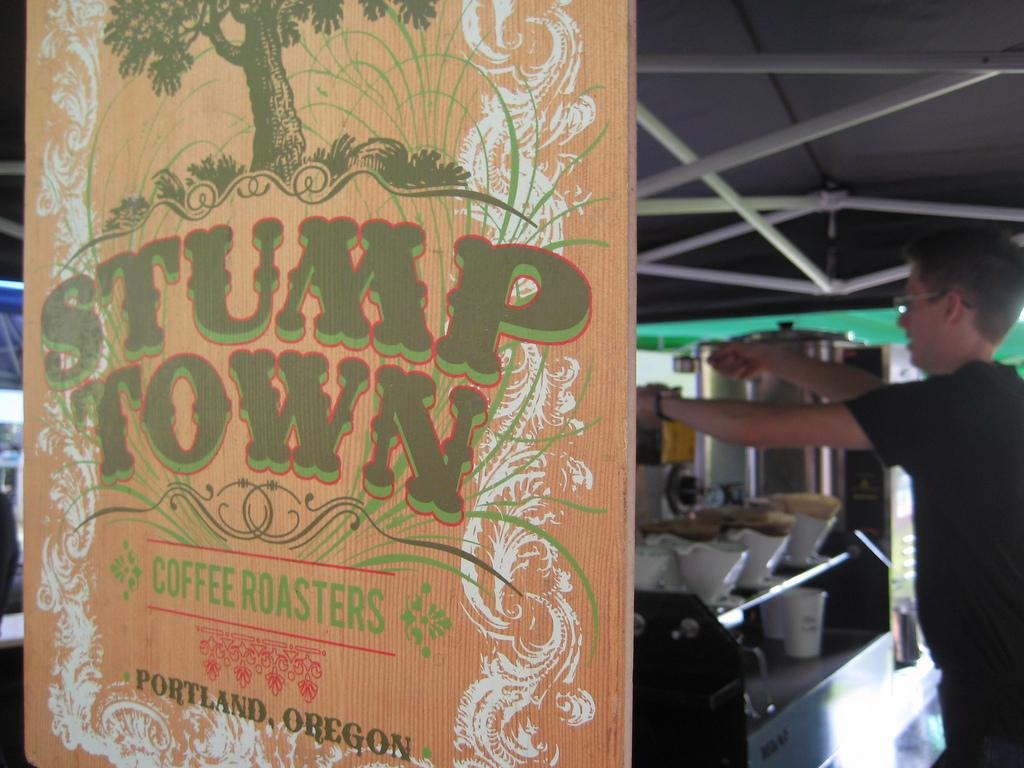Provide a one-sentence caption for the provided image. A sign that says Stump Town Coffee Roasters. 